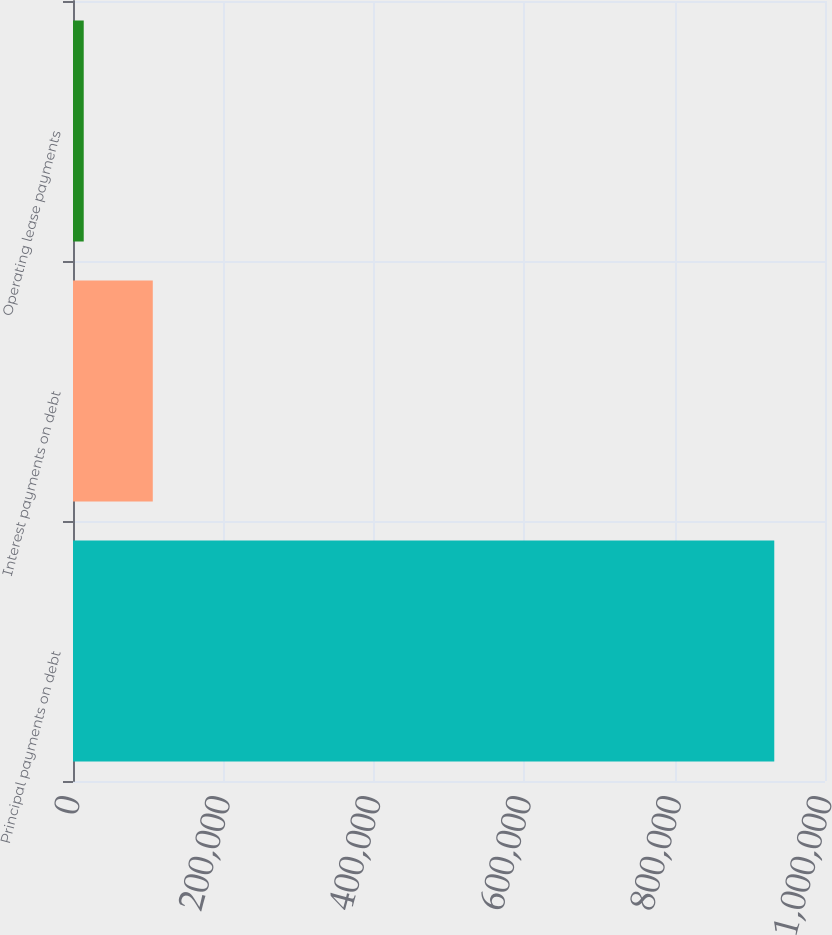Convert chart. <chart><loc_0><loc_0><loc_500><loc_500><bar_chart><fcel>Principal payments on debt<fcel>Interest payments on debt<fcel>Operating lease payments<nl><fcel>932540<fcel>106096<fcel>14269<nl></chart> 